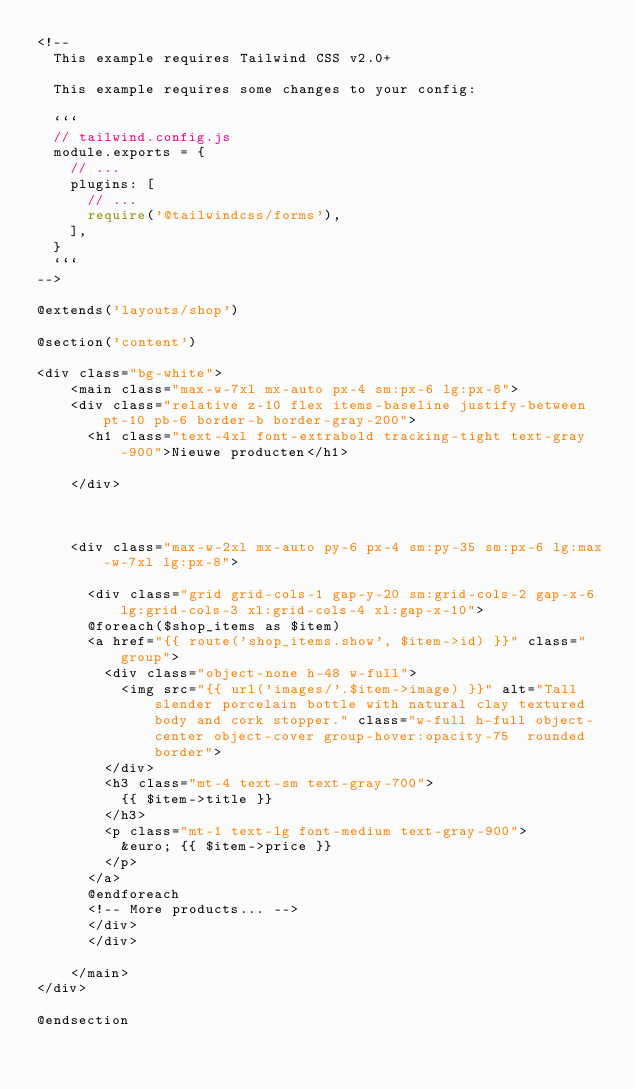<code> <loc_0><loc_0><loc_500><loc_500><_PHP_><!--
  This example requires Tailwind CSS v2.0+ 
  
  This example requires some changes to your config:
  
  ```
  // tailwind.config.js
  module.exports = {
    // ...
    plugins: [
      // ...
      require('@tailwindcss/forms'),
    ],
  }
  ```
-->

@extends('layouts/shop')

@section('content')

<div class="bg-white">
    <main class="max-w-7xl mx-auto px-4 sm:px-6 lg:px-8">
    <div class="relative z-10 flex items-baseline justify-between pt-10 pb-6 border-b border-gray-200">
      <h1 class="text-4xl font-extrabold tracking-tight text-gray-900">Nieuwe producten</h1>
      
    </div>
    

    
    <div class="max-w-2xl mx-auto py-6 px-4 sm:py-35 sm:px-6 lg:max-w-7xl lg:px-8">

      <div class="grid grid-cols-1 gap-y-20 sm:grid-cols-2 gap-x-6 lg:grid-cols-3 xl:grid-cols-4 xl:gap-x-10">
      @foreach($shop_items as $item)
      <a href="{{ route('shop_items.show', $item->id) }}" class="group">
        <div class="object-none h-48 w-full">
          <img src="{{ url('images/'.$item->image) }}" alt="Tall slender porcelain bottle with natural clay textured body and cork stopper." class="w-full h-full object-center object-cover group-hover:opacity-75  rounded border">
        </div>
        <h3 class="mt-4 text-sm text-gray-700">
          {{ $item->title }}
        </h3>
        <p class="mt-1 text-lg font-medium text-gray-900">
          &euro; {{ $item->price }}
        </p>
      </a>
      @endforeach
      <!-- More products... -->
      </div>
      </div>

    </main>
</div>

@endsection 

</code> 